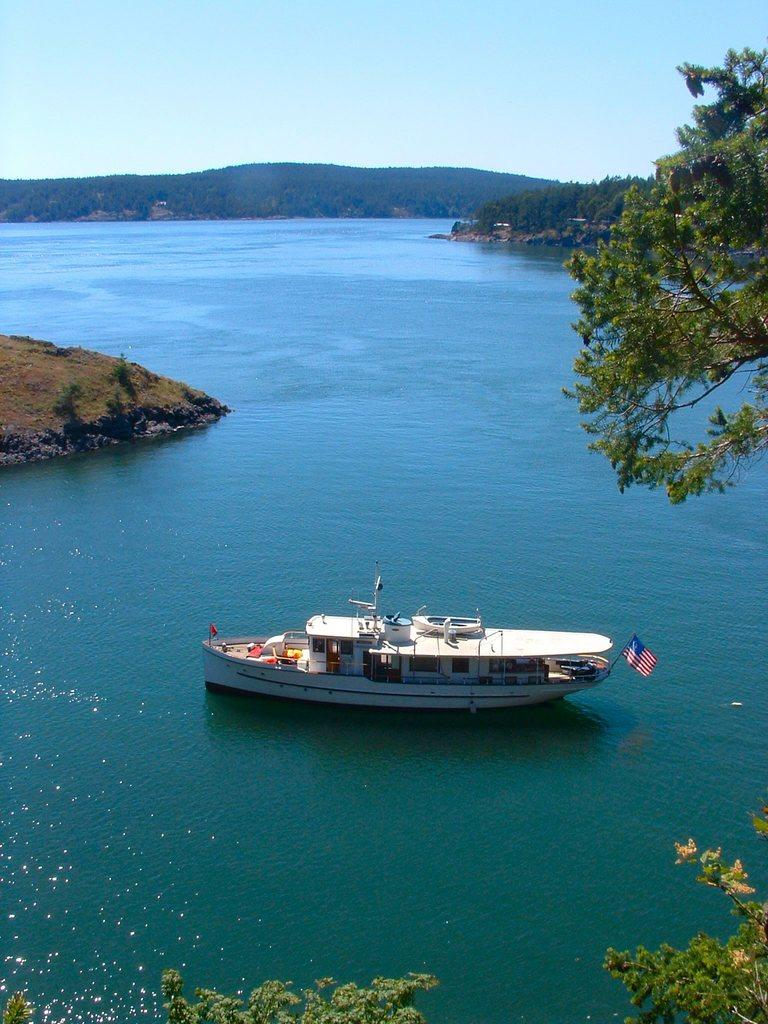What is the main subject of the image? The main subject of the image is a boat. Where is the boat located? The boat is on the water in the image. What can be seen in the background of the image? There are trees and hills in the background of the image. What type of rod is being used to solve the riddle in the image? There is no rod or riddle present in the image; it features a boat on the water with trees and hills in the background. 